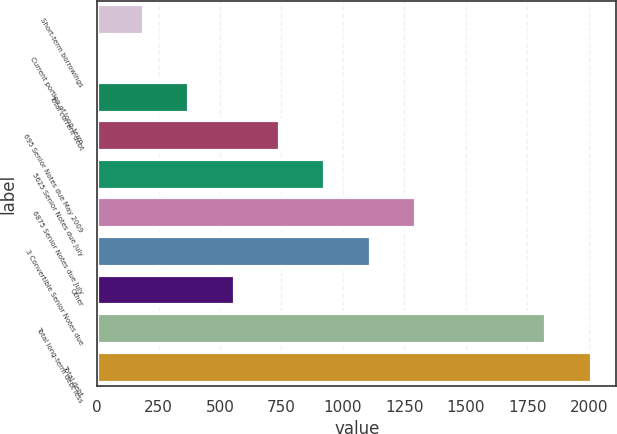Convert chart to OTSL. <chart><loc_0><loc_0><loc_500><loc_500><bar_chart><fcel>Short-term borrowings<fcel>Current portion of long-term<fcel>Total current debt<fcel>695 Senior Notes due May 2009<fcel>5625 Senior Notes due July<fcel>6875 Senior Notes due July<fcel>3 Convertible Senior Notes due<fcel>Other<fcel>Total long-term debt less<fcel>Total debt<nl><fcel>190.18<fcel>5.5<fcel>374.86<fcel>744.22<fcel>928.9<fcel>1298.26<fcel>1113.58<fcel>559.54<fcel>1826.6<fcel>2011.28<nl></chart> 